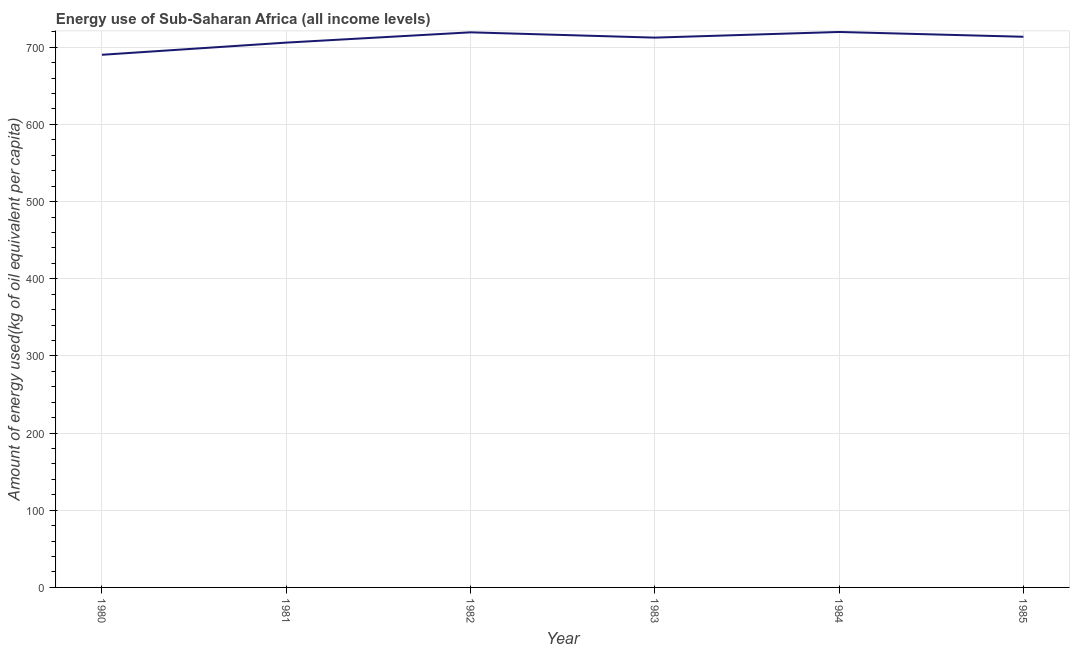What is the amount of energy used in 1981?
Keep it short and to the point. 706.02. Across all years, what is the maximum amount of energy used?
Give a very brief answer. 719.81. Across all years, what is the minimum amount of energy used?
Offer a terse response. 690.25. In which year was the amount of energy used maximum?
Offer a terse response. 1984. In which year was the amount of energy used minimum?
Make the answer very short. 1980. What is the sum of the amount of energy used?
Give a very brief answer. 4261.48. What is the difference between the amount of energy used in 1983 and 1985?
Your response must be concise. -1.12. What is the average amount of energy used per year?
Give a very brief answer. 710.25. What is the median amount of energy used?
Your answer should be compact. 713.03. Do a majority of the years between 1985 and 1984 (inclusive) have amount of energy used greater than 560 kg?
Give a very brief answer. No. What is the ratio of the amount of energy used in 1980 to that in 1981?
Ensure brevity in your answer.  0.98. What is the difference between the highest and the second highest amount of energy used?
Provide a short and direct response. 0.47. What is the difference between the highest and the lowest amount of energy used?
Offer a terse response. 29.56. In how many years, is the amount of energy used greater than the average amount of energy used taken over all years?
Provide a short and direct response. 4. Does the amount of energy used monotonically increase over the years?
Your response must be concise. No. How many lines are there?
Offer a very short reply. 1. How many years are there in the graph?
Your response must be concise. 6. What is the difference between two consecutive major ticks on the Y-axis?
Provide a short and direct response. 100. Are the values on the major ticks of Y-axis written in scientific E-notation?
Make the answer very short. No. Does the graph contain grids?
Ensure brevity in your answer.  Yes. What is the title of the graph?
Your response must be concise. Energy use of Sub-Saharan Africa (all income levels). What is the label or title of the Y-axis?
Keep it short and to the point. Amount of energy used(kg of oil equivalent per capita). What is the Amount of energy used(kg of oil equivalent per capita) of 1980?
Ensure brevity in your answer.  690.25. What is the Amount of energy used(kg of oil equivalent per capita) in 1981?
Make the answer very short. 706.02. What is the Amount of energy used(kg of oil equivalent per capita) of 1982?
Your answer should be very brief. 719.34. What is the Amount of energy used(kg of oil equivalent per capita) in 1983?
Offer a terse response. 712.47. What is the Amount of energy used(kg of oil equivalent per capita) in 1984?
Offer a terse response. 719.81. What is the Amount of energy used(kg of oil equivalent per capita) of 1985?
Provide a short and direct response. 713.59. What is the difference between the Amount of energy used(kg of oil equivalent per capita) in 1980 and 1981?
Your answer should be compact. -15.76. What is the difference between the Amount of energy used(kg of oil equivalent per capita) in 1980 and 1982?
Make the answer very short. -29.09. What is the difference between the Amount of energy used(kg of oil equivalent per capita) in 1980 and 1983?
Your answer should be compact. -22.22. What is the difference between the Amount of energy used(kg of oil equivalent per capita) in 1980 and 1984?
Your answer should be compact. -29.56. What is the difference between the Amount of energy used(kg of oil equivalent per capita) in 1980 and 1985?
Offer a very short reply. -23.34. What is the difference between the Amount of energy used(kg of oil equivalent per capita) in 1981 and 1982?
Your response must be concise. -13.32. What is the difference between the Amount of energy used(kg of oil equivalent per capita) in 1981 and 1983?
Ensure brevity in your answer.  -6.46. What is the difference between the Amount of energy used(kg of oil equivalent per capita) in 1981 and 1984?
Provide a short and direct response. -13.8. What is the difference between the Amount of energy used(kg of oil equivalent per capita) in 1981 and 1985?
Keep it short and to the point. -7.58. What is the difference between the Amount of energy used(kg of oil equivalent per capita) in 1982 and 1983?
Offer a terse response. 6.87. What is the difference between the Amount of energy used(kg of oil equivalent per capita) in 1982 and 1984?
Your answer should be very brief. -0.47. What is the difference between the Amount of energy used(kg of oil equivalent per capita) in 1982 and 1985?
Your answer should be compact. 5.75. What is the difference between the Amount of energy used(kg of oil equivalent per capita) in 1983 and 1984?
Ensure brevity in your answer.  -7.34. What is the difference between the Amount of energy used(kg of oil equivalent per capita) in 1983 and 1985?
Your answer should be compact. -1.12. What is the difference between the Amount of energy used(kg of oil equivalent per capita) in 1984 and 1985?
Provide a succinct answer. 6.22. What is the ratio of the Amount of energy used(kg of oil equivalent per capita) in 1980 to that in 1981?
Offer a terse response. 0.98. What is the ratio of the Amount of energy used(kg of oil equivalent per capita) in 1980 to that in 1982?
Offer a very short reply. 0.96. What is the ratio of the Amount of energy used(kg of oil equivalent per capita) in 1980 to that in 1984?
Provide a succinct answer. 0.96. What is the ratio of the Amount of energy used(kg of oil equivalent per capita) in 1981 to that in 1982?
Ensure brevity in your answer.  0.98. What is the ratio of the Amount of energy used(kg of oil equivalent per capita) in 1981 to that in 1983?
Make the answer very short. 0.99. What is the ratio of the Amount of energy used(kg of oil equivalent per capita) in 1982 to that in 1983?
Keep it short and to the point. 1.01. What is the ratio of the Amount of energy used(kg of oil equivalent per capita) in 1982 to that in 1984?
Keep it short and to the point. 1. What is the ratio of the Amount of energy used(kg of oil equivalent per capita) in 1982 to that in 1985?
Keep it short and to the point. 1.01. What is the ratio of the Amount of energy used(kg of oil equivalent per capita) in 1983 to that in 1985?
Keep it short and to the point. 1. 